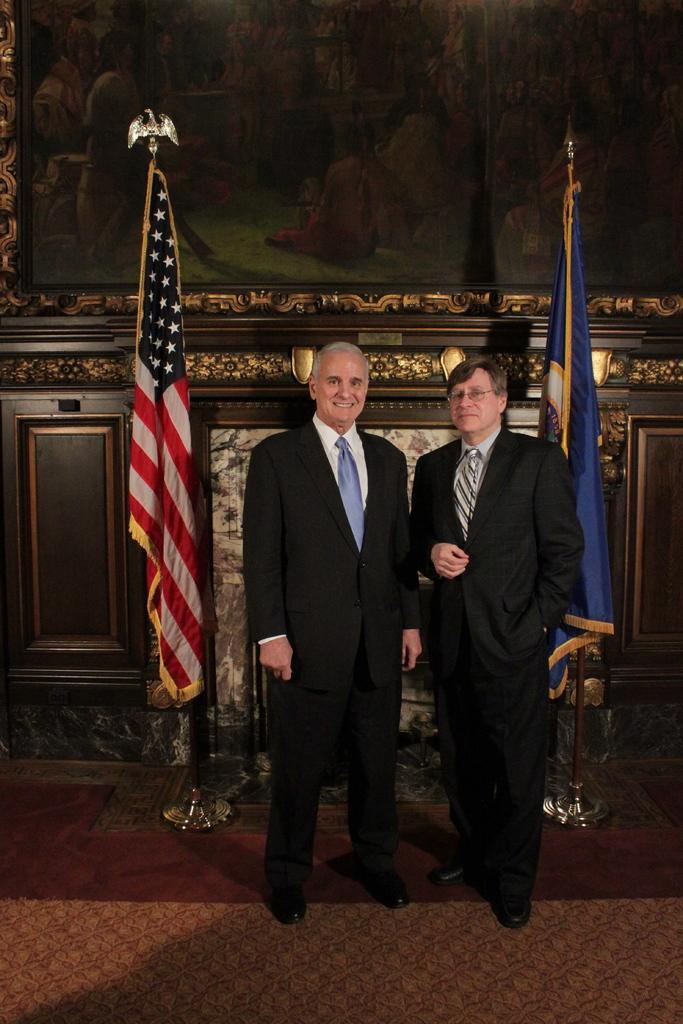Could you give a brief overview of what you see in this image? In the image there are two men standing. Behind them there are poles with flags. And also there is a wall with frame and also there are designs on the wall. 